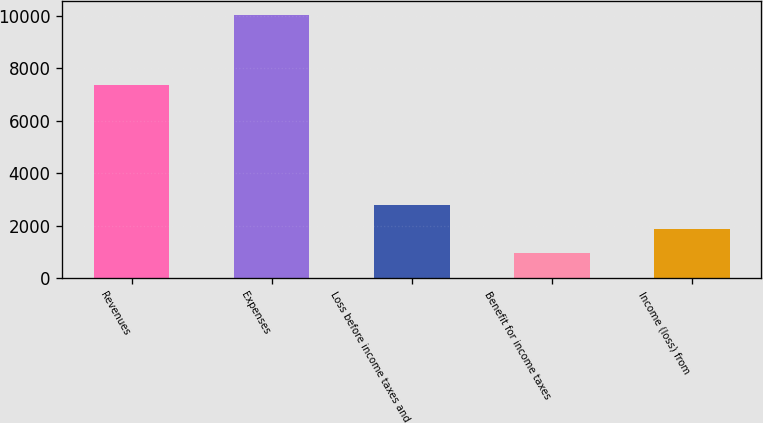Convert chart. <chart><loc_0><loc_0><loc_500><loc_500><bar_chart><fcel>Revenues<fcel>Expenses<fcel>Loss before income taxes and<fcel>Benefit for income taxes<fcel>Income (loss) from<nl><fcel>7364<fcel>10048<fcel>2784.8<fcel>969<fcel>1876.9<nl></chart> 